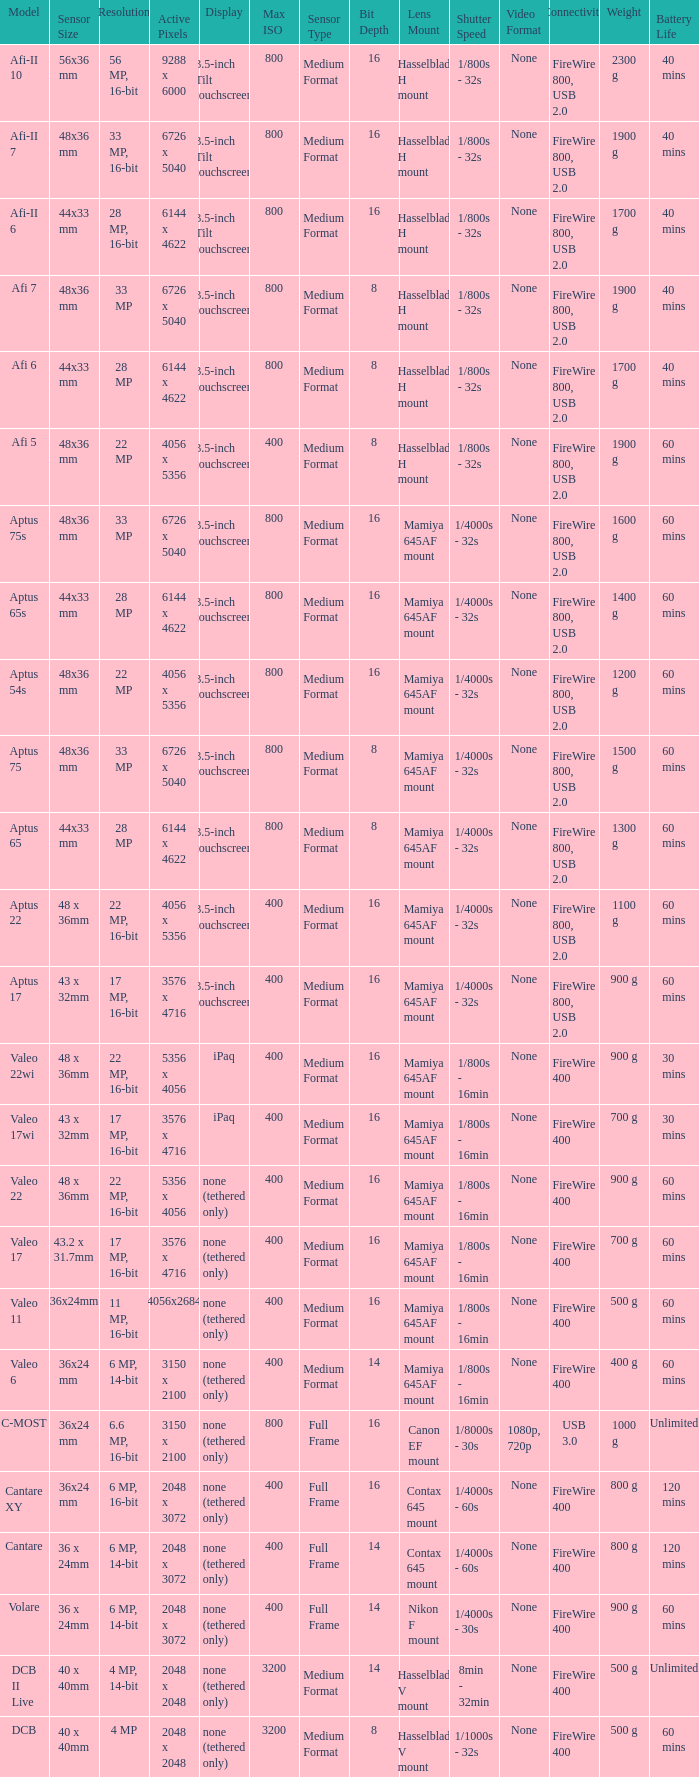Which model has a sensor sized 48x36 mm, pixels of 6726 x 5040, and a 33 mp resolution? Afi 7, Aptus 75s, Aptus 75. 